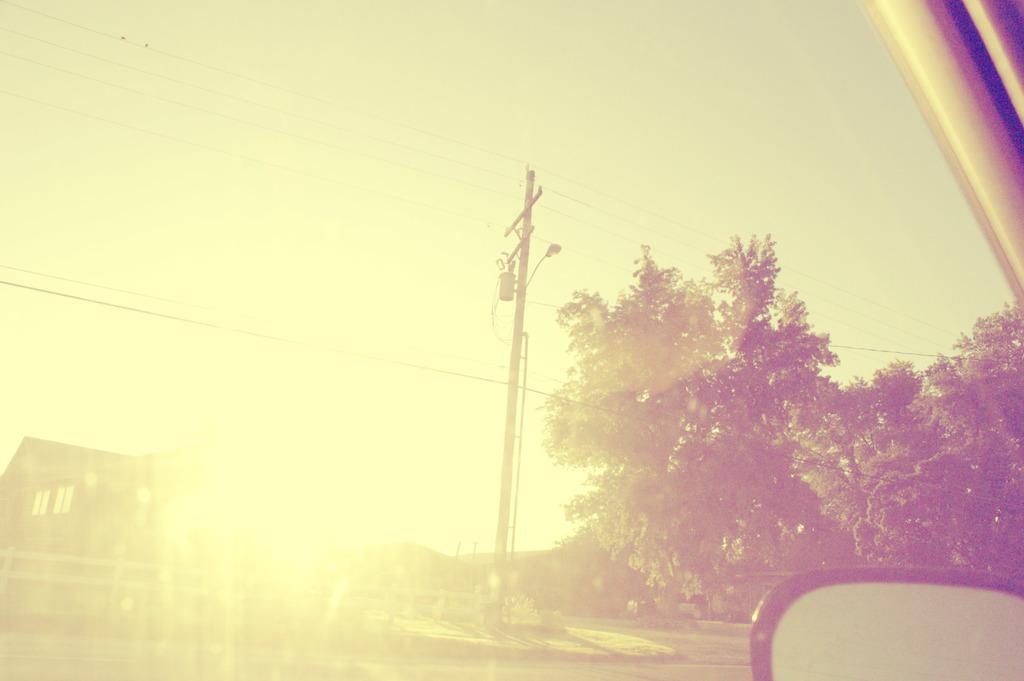In one or two sentences, can you explain what this image depicts? At the bottom of the image there is a side mirror, at the top right of the image there is car door, in this image there are trees, electric pole with lamp and cables on it, behind that there are houses. 